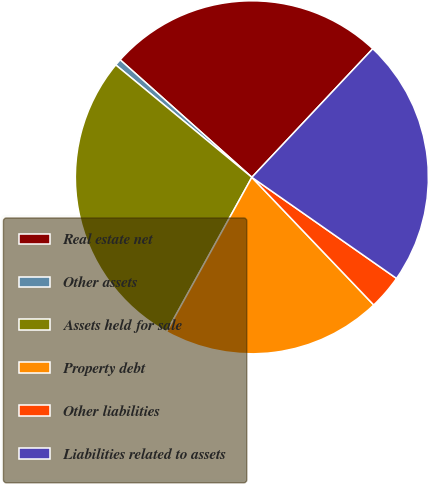Convert chart. <chart><loc_0><loc_0><loc_500><loc_500><pie_chart><fcel>Real estate net<fcel>Other assets<fcel>Assets held for sale<fcel>Property debt<fcel>Other liabilities<fcel>Liabilities related to assets<nl><fcel>25.42%<fcel>0.61%<fcel>27.96%<fcel>20.16%<fcel>3.16%<fcel>22.7%<nl></chart> 